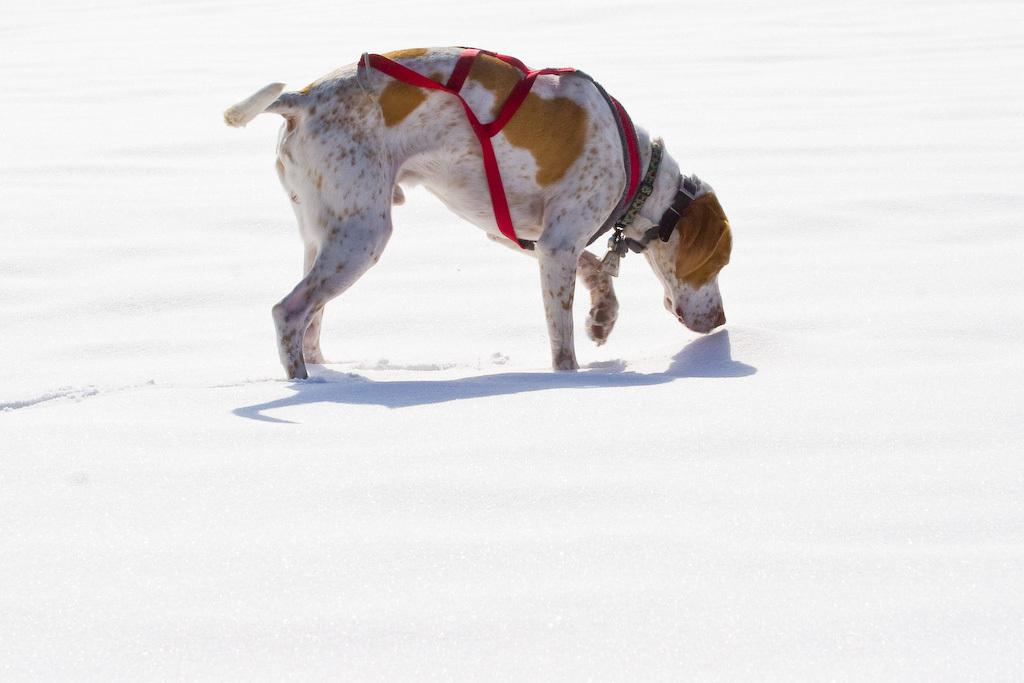What animal is present in the image? There is a dog in the image. What is the dog doing in the image? The dog is walking in the snow. What distinguishing feature does the dog have? The dog has a red-colored belt. What type of crime is being committed by the dog's friends in the image? There is no mention of friends or crime in the image; it only features a dog walking in the snow with a red-colored belt. 